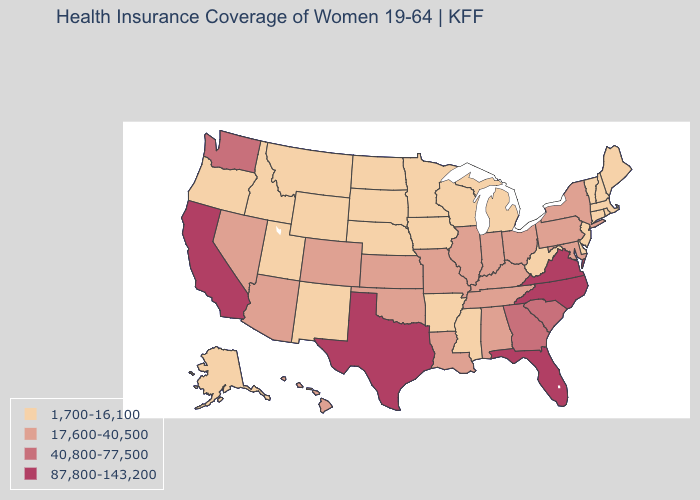How many symbols are there in the legend?
Be succinct. 4. What is the lowest value in states that border New Hampshire?
Concise answer only. 1,700-16,100. What is the value of Georgia?
Be succinct. 40,800-77,500. Which states have the highest value in the USA?
Be succinct. California, Florida, North Carolina, Texas, Virginia. Does the map have missing data?
Quick response, please. No. Name the states that have a value in the range 40,800-77,500?
Answer briefly. Georgia, South Carolina, Washington. How many symbols are there in the legend?
Keep it brief. 4. Does the map have missing data?
Give a very brief answer. No. What is the value of Wisconsin?
Answer briefly. 1,700-16,100. Does California have the highest value in the West?
Answer briefly. Yes. Among the states that border West Virginia , which have the lowest value?
Keep it brief. Kentucky, Maryland, Ohio, Pennsylvania. What is the value of Pennsylvania?
Concise answer only. 17,600-40,500. What is the lowest value in states that border New Mexico?
Short answer required. 1,700-16,100. Among the states that border Colorado , does Oklahoma have the lowest value?
Be succinct. No. Does Rhode Island have the lowest value in the Northeast?
Write a very short answer. Yes. 